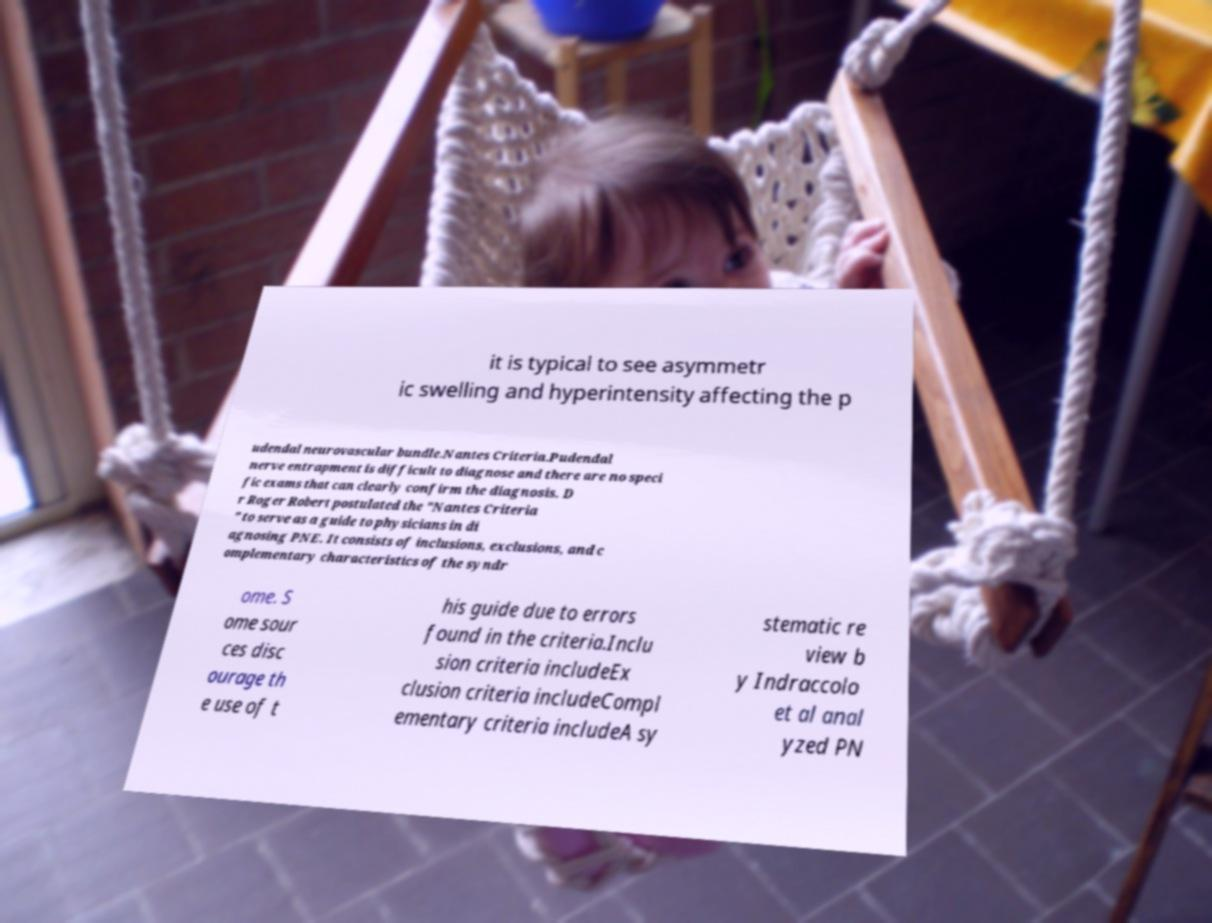There's text embedded in this image that I need extracted. Can you transcribe it verbatim? it is typical to see asymmetr ic swelling and hyperintensity affecting the p udendal neurovascular bundle.Nantes Criteria.Pudendal nerve entrapment is difficult to diagnose and there are no speci fic exams that can clearly confirm the diagnosis. D r Roger Robert postulated the "Nantes Criteria " to serve as a guide to physicians in di agnosing PNE. It consists of inclusions, exclusions, and c omplementary characteristics of the syndr ome. S ome sour ces disc ourage th e use of t his guide due to errors found in the criteria.Inclu sion criteria includeEx clusion criteria includeCompl ementary criteria includeA sy stematic re view b y Indraccolo et al anal yzed PN 